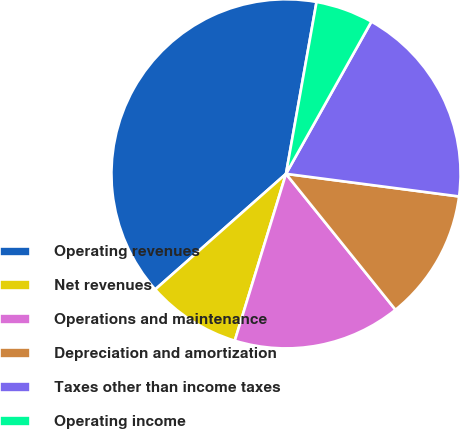Convert chart. <chart><loc_0><loc_0><loc_500><loc_500><pie_chart><fcel>Operating revenues<fcel>Net revenues<fcel>Operations and maintenance<fcel>Depreciation and amortization<fcel>Taxes other than income taxes<fcel>Operating income<nl><fcel>39.32%<fcel>8.74%<fcel>15.53%<fcel>12.14%<fcel>18.93%<fcel>5.34%<nl></chart> 